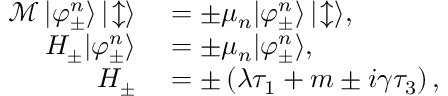Convert formula to latex. <formula><loc_0><loc_0><loc_500><loc_500>\begin{array} { r l } { \mathcal { M } \, | \varphi _ { \pm } ^ { n } \rangle \, | \, \updownarrow \rangle } & = \pm \mu _ { n } | \varphi _ { \pm } ^ { n } \rangle \, | \, \updownarrow \rangle , } \\ { H _ { \pm } | \varphi _ { \pm } ^ { n } \rangle } & = \pm \mu _ { n } | \varphi _ { \pm } ^ { n } \rangle , } \\ { H _ { \pm } } & = \pm \left ( \lambda \tau _ { 1 } + m \pm i \gamma \tau _ { 3 } \right ) , } \end{array}</formula> 